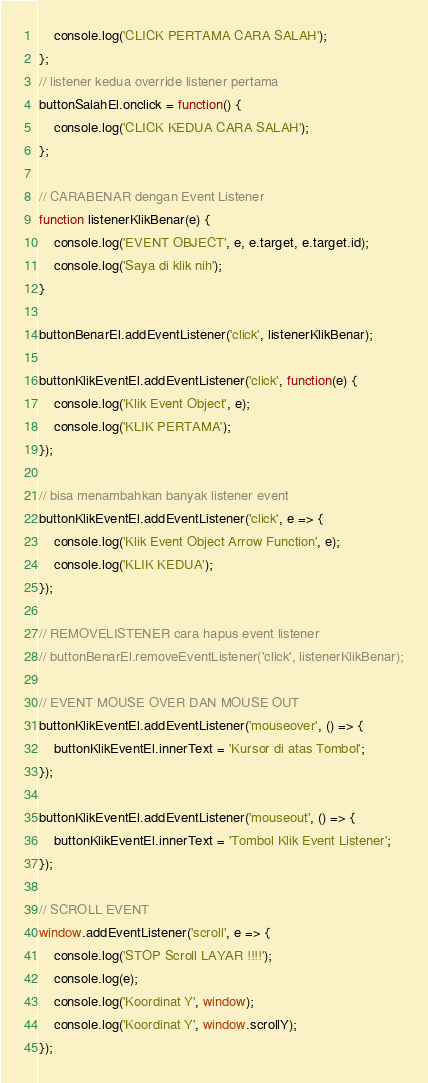Convert code to text. <code><loc_0><loc_0><loc_500><loc_500><_JavaScript_>    console.log('CLICK PERTAMA CARA SALAH');
};
// listener kedua override listener pertama
buttonSalahEl.onclick = function() {
    console.log('CLICK KEDUA CARA SALAH');
};

// CARABENAR dengan Event Listener
function listenerKlikBenar(e) {
    console.log('EVENT OBJECT', e, e.target, e.target.id);
    console.log('Saya di klik nih');
}

buttonBenarEl.addEventListener('click', listenerKlikBenar);

buttonKlikEventEl.addEventListener('click', function(e) {
    console.log('Klik Event Object', e);
    console.log('KLIK PERTAMA');
});

// bisa menambahkan banyak listener event
buttonKlikEventEl.addEventListener('click', e => {
    console.log('Klik Event Object Arrow Function', e);
    console.log('KLIK KEDUA');
});

// REMOVELISTENER cara hapus event listener
// buttonBenarEl.removeEventListener('click', listenerKlikBenar);

// EVENT MOUSE OVER DAN MOUSE OUT
buttonKlikEventEl.addEventListener('mouseover', () => {
    buttonKlikEventEl.innerText = 'Kursor di atas Tombol';
});

buttonKlikEventEl.addEventListener('mouseout', () => {
    buttonKlikEventEl.innerText = 'Tombol Klik Event Listener';
});

// SCROLL EVENT
window.addEventListener('scroll', e => {
    console.log('STOP Scroll LAYAR !!!!');
    console.log(e);
    console.log('Koordinat Y', window);
    console.log('Koordinat Y', window.scrollY);
});
</code> 